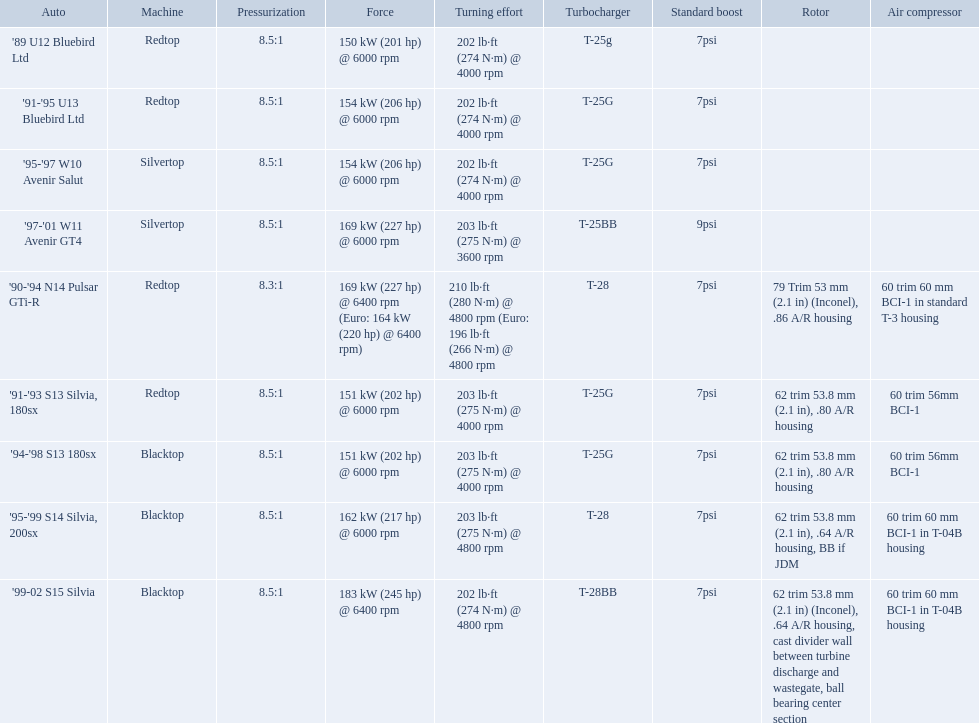What are the listed hp of the cars? 150 kW (201 hp) @ 6000 rpm, 154 kW (206 hp) @ 6000 rpm, 154 kW (206 hp) @ 6000 rpm, 169 kW (227 hp) @ 6000 rpm, 169 kW (227 hp) @ 6400 rpm (Euro: 164 kW (220 hp) @ 6400 rpm), 151 kW (202 hp) @ 6000 rpm, 151 kW (202 hp) @ 6000 rpm, 162 kW (217 hp) @ 6000 rpm, 183 kW (245 hp) @ 6400 rpm. Which is the only car with over 230 hp? '99-02 S15 Silvia. What are the psi's? 7psi, 7psi, 7psi, 9psi, 7psi, 7psi, 7psi, 7psi, 7psi. What are the number(s) greater than 7? 9psi. Which car has that number? '97-'01 W11 Avenir GT4. What are all the cars? '89 U12 Bluebird Ltd, '91-'95 U13 Bluebird Ltd, '95-'97 W10 Avenir Salut, '97-'01 W11 Avenir GT4, '90-'94 N14 Pulsar GTi-R, '91-'93 S13 Silvia, 180sx, '94-'98 S13 180sx, '95-'99 S14 Silvia, 200sx, '99-02 S15 Silvia. What are their stock boosts? 7psi, 7psi, 7psi, 9psi, 7psi, 7psi, 7psi, 7psi, 7psi. And which car has the highest stock boost? '97-'01 W11 Avenir GT4. Which cars list turbine details? '90-'94 N14 Pulsar GTi-R, '91-'93 S13 Silvia, 180sx, '94-'98 S13 180sx, '95-'99 S14 Silvia, 200sx, '99-02 S15 Silvia. Which of these hit their peak hp at the highest rpm? '90-'94 N14 Pulsar GTi-R, '99-02 S15 Silvia. Of those what is the compression of the only engine that isn't blacktop?? 8.3:1. 